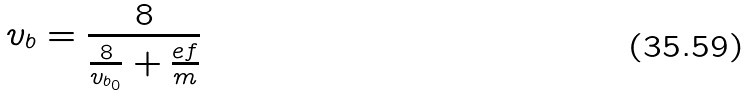<formula> <loc_0><loc_0><loc_500><loc_500>v _ { b } = \frac { 8 } { \frac { 8 } { v _ { b _ { 0 } } } + \frac { e f } { m } }</formula> 